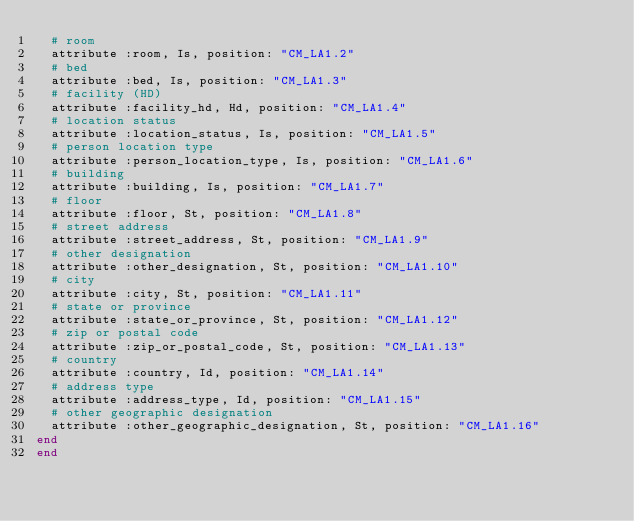Convert code to text. <code><loc_0><loc_0><loc_500><loc_500><_Ruby_>  # room
  attribute :room, Is, position: "CM_LA1.2"
  # bed
  attribute :bed, Is, position: "CM_LA1.3"
  # facility (HD)
  attribute :facility_hd, Hd, position: "CM_LA1.4"
  # location status
  attribute :location_status, Is, position: "CM_LA1.5"
  # person location type
  attribute :person_location_type, Is, position: "CM_LA1.6"
  # building
  attribute :building, Is, position: "CM_LA1.7"
  # floor
  attribute :floor, St, position: "CM_LA1.8"
  # street address
  attribute :street_address, St, position: "CM_LA1.9"
  # other designation
  attribute :other_designation, St, position: "CM_LA1.10"
  # city
  attribute :city, St, position: "CM_LA1.11"
  # state or province
  attribute :state_or_province, St, position: "CM_LA1.12"
  # zip or postal code
  attribute :zip_or_postal_code, St, position: "CM_LA1.13"
  # country
  attribute :country, Id, position: "CM_LA1.14"
  # address type
  attribute :address_type, Id, position: "CM_LA1.15"
  # other geographic designation
  attribute :other_geographic_designation, St, position: "CM_LA1.16"
end
end</code> 